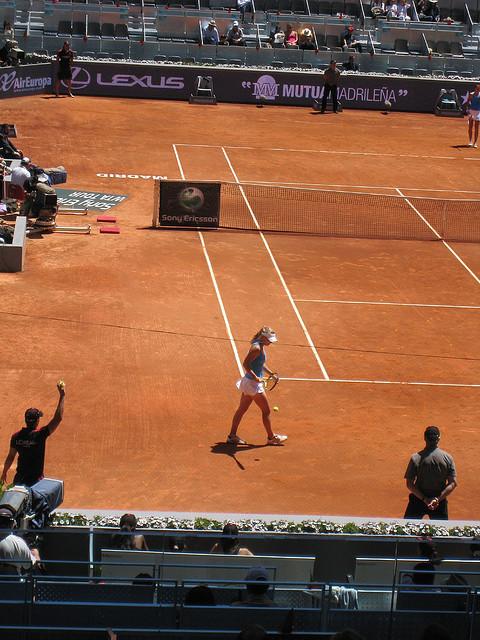What color is the court?
Quick response, please. Brown. Is the pickle uneaten?
Answer briefly. No. What sport are they playing?
Give a very brief answer. Tennis. 